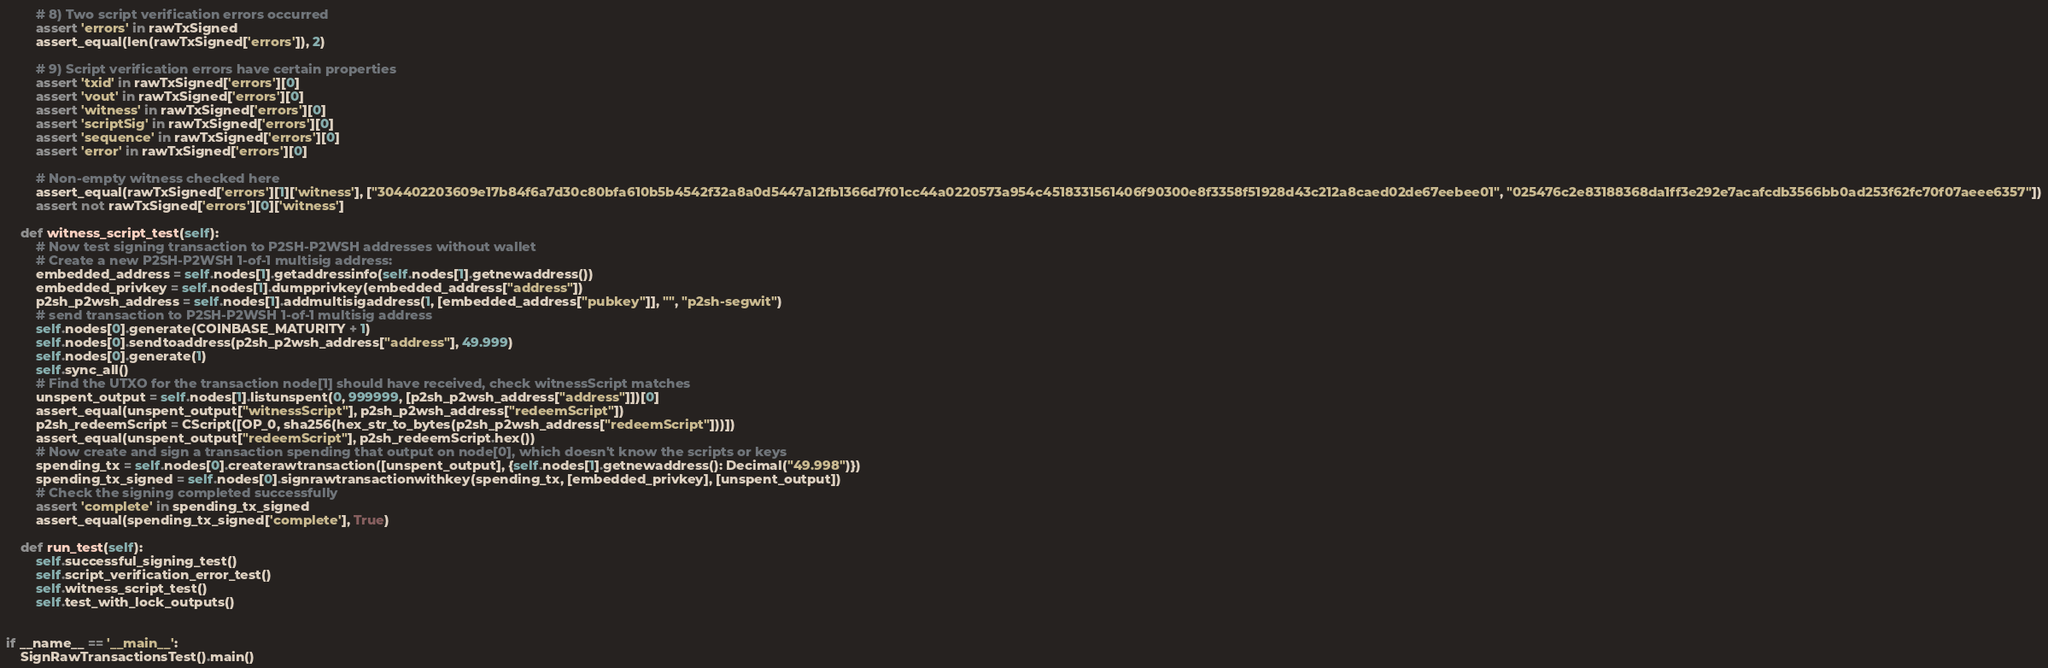Convert code to text. <code><loc_0><loc_0><loc_500><loc_500><_Python_>
        # 8) Two script verification errors occurred
        assert 'errors' in rawTxSigned
        assert_equal(len(rawTxSigned['errors']), 2)

        # 9) Script verification errors have certain properties
        assert 'txid' in rawTxSigned['errors'][0]
        assert 'vout' in rawTxSigned['errors'][0]
        assert 'witness' in rawTxSigned['errors'][0]
        assert 'scriptSig' in rawTxSigned['errors'][0]
        assert 'sequence' in rawTxSigned['errors'][0]
        assert 'error' in rawTxSigned['errors'][0]

        # Non-empty witness checked here
        assert_equal(rawTxSigned['errors'][1]['witness'], ["304402203609e17b84f6a7d30c80bfa610b5b4542f32a8a0d5447a12fb1366d7f01cc44a0220573a954c4518331561406f90300e8f3358f51928d43c212a8caed02de67eebee01", "025476c2e83188368da1ff3e292e7acafcdb3566bb0ad253f62fc70f07aeee6357"])
        assert not rawTxSigned['errors'][0]['witness']

    def witness_script_test(self):
        # Now test signing transaction to P2SH-P2WSH addresses without wallet
        # Create a new P2SH-P2WSH 1-of-1 multisig address:
        embedded_address = self.nodes[1].getaddressinfo(self.nodes[1].getnewaddress())
        embedded_privkey = self.nodes[1].dumpprivkey(embedded_address["address"])
        p2sh_p2wsh_address = self.nodes[1].addmultisigaddress(1, [embedded_address["pubkey"]], "", "p2sh-segwit")
        # send transaction to P2SH-P2WSH 1-of-1 multisig address
        self.nodes[0].generate(COINBASE_MATURITY + 1)
        self.nodes[0].sendtoaddress(p2sh_p2wsh_address["address"], 49.999)
        self.nodes[0].generate(1)
        self.sync_all()
        # Find the UTXO for the transaction node[1] should have received, check witnessScript matches
        unspent_output = self.nodes[1].listunspent(0, 999999, [p2sh_p2wsh_address["address"]])[0]
        assert_equal(unspent_output["witnessScript"], p2sh_p2wsh_address["redeemScript"])
        p2sh_redeemScript = CScript([OP_0, sha256(hex_str_to_bytes(p2sh_p2wsh_address["redeemScript"]))])
        assert_equal(unspent_output["redeemScript"], p2sh_redeemScript.hex())
        # Now create and sign a transaction spending that output on node[0], which doesn't know the scripts or keys
        spending_tx = self.nodes[0].createrawtransaction([unspent_output], {self.nodes[1].getnewaddress(): Decimal("49.998")})
        spending_tx_signed = self.nodes[0].signrawtransactionwithkey(spending_tx, [embedded_privkey], [unspent_output])
        # Check the signing completed successfully
        assert 'complete' in spending_tx_signed
        assert_equal(spending_tx_signed['complete'], True)

    def run_test(self):
        self.successful_signing_test()
        self.script_verification_error_test()
        self.witness_script_test()
        self.test_with_lock_outputs()


if __name__ == '__main__':
    SignRawTransactionsTest().main()
</code> 